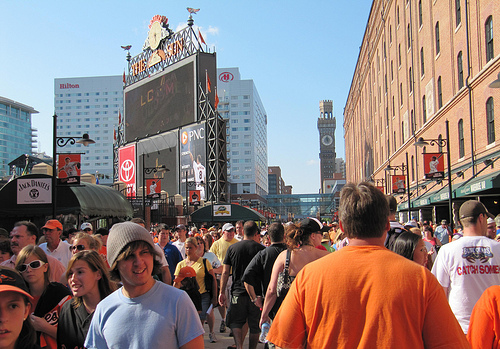<image>
Is the building behind the building? No. The building is not behind the building. From this viewpoint, the building appears to be positioned elsewhere in the scene. 